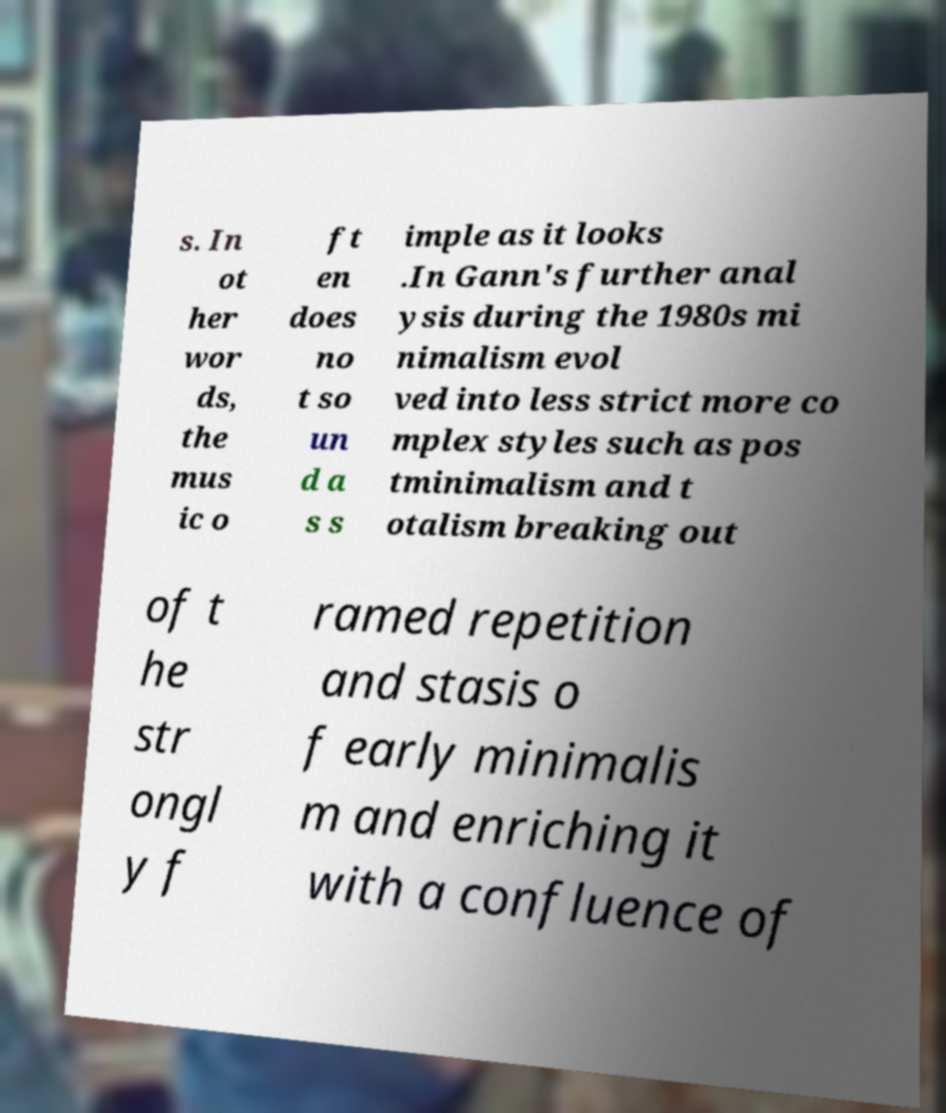Can you accurately transcribe the text from the provided image for me? s. In ot her wor ds, the mus ic o ft en does no t so un d a s s imple as it looks .In Gann's further anal ysis during the 1980s mi nimalism evol ved into less strict more co mplex styles such as pos tminimalism and t otalism breaking out of t he str ongl y f ramed repetition and stasis o f early minimalis m and enriching it with a confluence of 